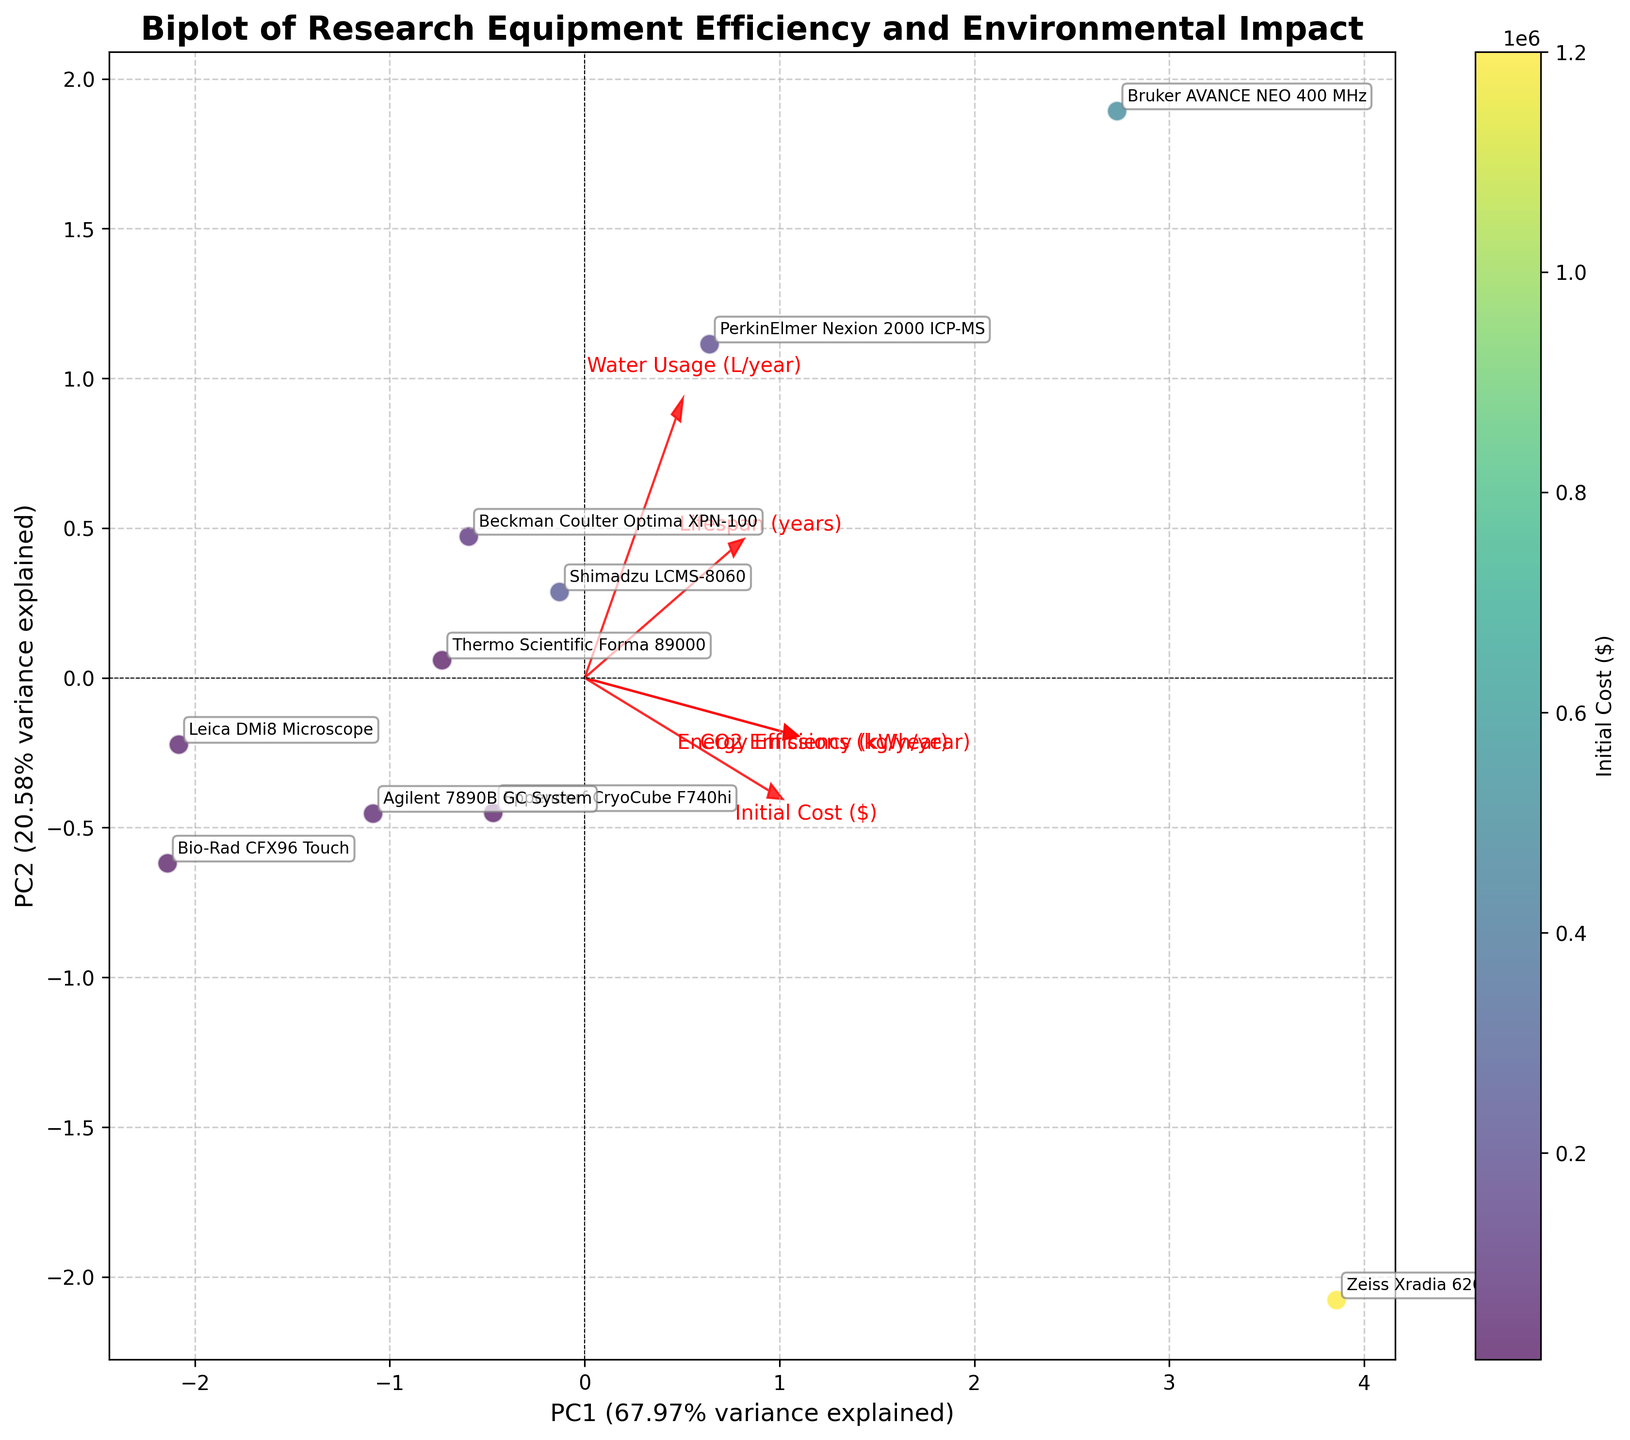What is the title of the biplot? The title of the biplot is typically found at the top of the figure. It is displayed in large, bold text to summarize the content and purpose of the plot.
Answer: "Biplot of Research Equipment Efficiency and Environmental Impact" How many principal components are displayed in the biplot? In a biplot, the number of principal components is indicated by the axes, usually labeled as PC1, PC2, etc. The biplot in this case shows two such components, which can be identified by their labels.
Answer: 2 Which equipment model has the highest initial cost in the biplot? By examining the color gradient on the scatter points, which is guided by the colorbar indicating initial costs, the equipment with the deepest color represents the highest cost. Additionally, annotations next to the scatter points help identify the specific models.
Answer: Zeiss Xradia 620 Versa What percentage of variance is explained by the first principal component (PC1)? The x-axis of the biplot is labeled with PC1, followed by a percentage that represents the variance it explains. This value is usually calculated during PCA and succinctly displayed in the axis label.
Answer: 51.29% How are 'CO2 Emissions' and 'Energy Efficiency' related in the biplot? By examining the direction and length of the arrows representing 'CO2 Emissions' and 'Energy Efficiency', one can infer their relationship. If the arrows point in the same or similar direction, they are positively correlated; if opposite, they are negatively correlated.
Answer: Positively correlated Which equipment model is positioned closest to the origin in the biplot? The origin is the (0,0) point on the biplot. The equipment model whose corresponding data point is nearest to this point in the scatter plot is the closest to the origin.
Answer: Leica DMi8 Microscope How does 'Lifespan (years)' relate to the principal components? The relationship can be identified by the direction and magnitude of the arrow labeled 'Lifespan (years)'. It indicates how this feature loads on the two principal components and is typically evaluated by its angle and length relative to PC1 and PC2 axes.
Answer: More aligned with PC2 Which equipment model has the highest value on PC1? By locating the data point farthest to the right on the x-axis (PC1), and checking the annotation label for that point, one can determine the equipment model assigned to this position.
Answer: Bruker AVANCE NEO 400 MHz Is there a notable trade-off between 'Initial Cost ($)' and 'Water Usage (L/year)'? To determine this, observe the direction and placement of the arrows representing 'Initial Cost ($)' and 'Water Usage (L/year)'. If the arrows point in opposite directions, a trade-off is likely indicated.
Answer: Yes, they show a negative relationship 